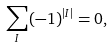<formula> <loc_0><loc_0><loc_500><loc_500>\sum _ { I } ( - 1 ) ^ { | I | } = 0 ,</formula> 